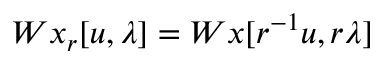<formula> <loc_0><loc_0><loc_500><loc_500>W x _ { r } [ u , \lambda ] = W x [ r ^ { - 1 } u , r \lambda ]</formula> 